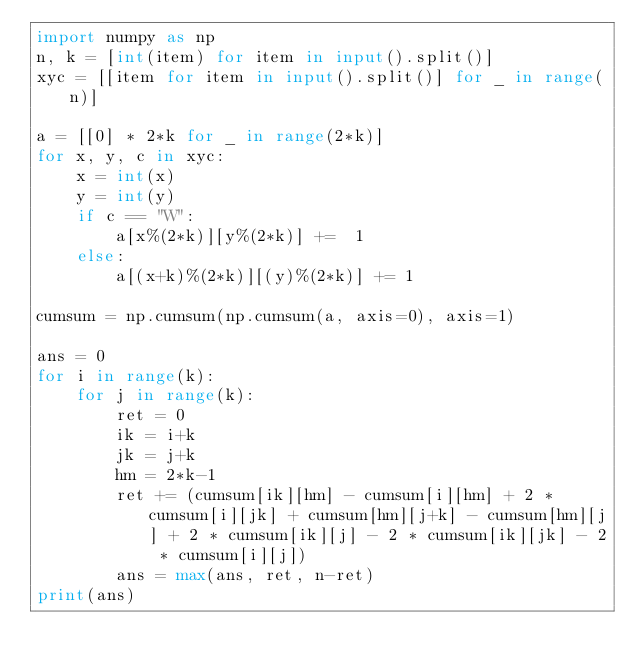Convert code to text. <code><loc_0><loc_0><loc_500><loc_500><_Python_>import numpy as np
n, k = [int(item) for item in input().split()]
xyc = [[item for item in input().split()] for _ in range(n)]

a = [[0] * 2*k for _ in range(2*k)]
for x, y, c in xyc:
    x = int(x)
    y = int(y)
    if c == "W":
        a[x%(2*k)][y%(2*k)] +=  1
    else: 
        a[(x+k)%(2*k)][(y)%(2*k)] += 1

cumsum = np.cumsum(np.cumsum(a, axis=0), axis=1)

ans = 0
for i in range(k):
    for j in range(k):
        ret = 0
        ik = i+k
        jk = j+k
        hm = 2*k-1
        ret += (cumsum[ik][hm] - cumsum[i][hm] + 2 * cumsum[i][jk] + cumsum[hm][j+k] - cumsum[hm][j] + 2 * cumsum[ik][j] - 2 * cumsum[ik][jk] - 2 * cumsum[i][j])
        ans = max(ans, ret, n-ret)
print(ans)</code> 